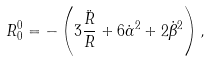Convert formula to latex. <formula><loc_0><loc_0><loc_500><loc_500>R _ { 0 } ^ { 0 } = - \left ( 3 \frac { \ddot { R } } { R } + 6 \dot { \alpha } ^ { 2 } + 2 \dot { \beta } ^ { 2 } \right ) ,</formula> 